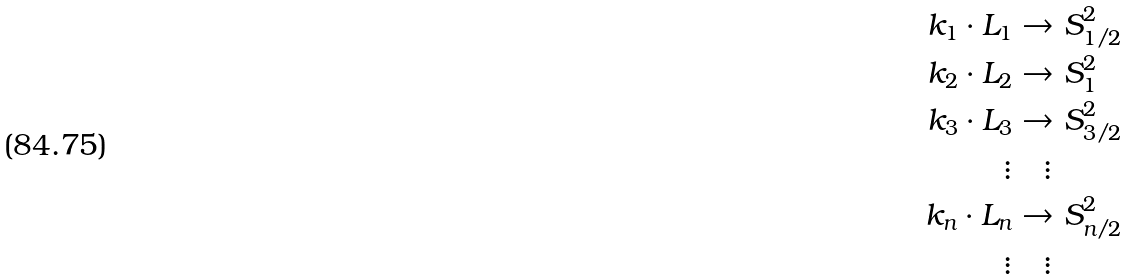Convert formula to latex. <formula><loc_0><loc_0><loc_500><loc_500>k _ { 1 } \cdot L _ { 1 } & \to S ^ { 2 } _ { 1 / 2 } \\ k _ { 2 } \cdot L _ { 2 } & \to S ^ { 2 } _ { 1 } \\ k _ { 3 } \cdot L _ { 3 } & \to S ^ { 2 } _ { 3 / 2 } \\ \vdots & \quad \vdots \\ k _ { n } \cdot L _ { n } & \to S ^ { 2 } _ { n / 2 } \\ \vdots & \quad \vdots</formula> 